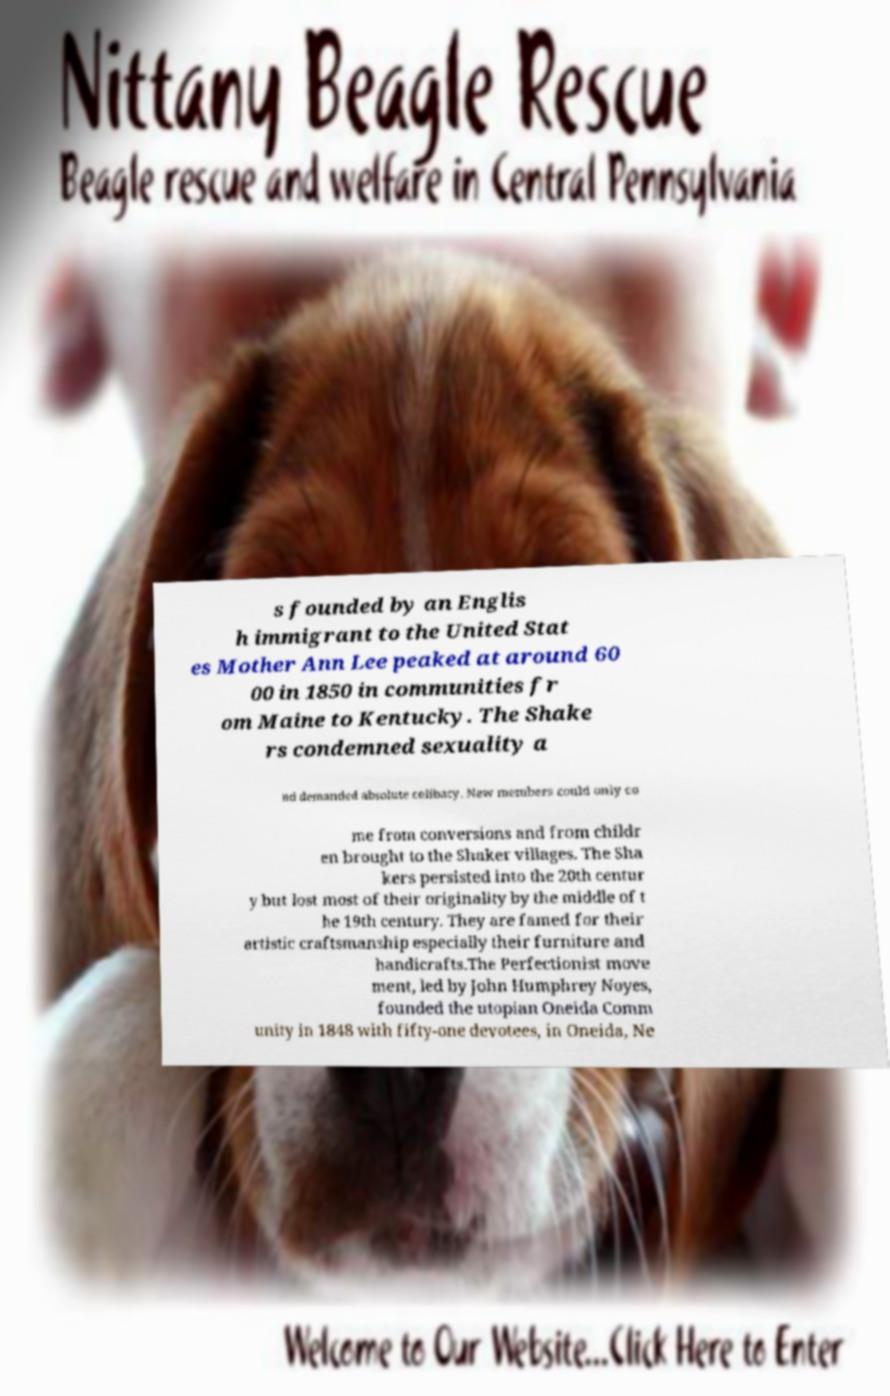Can you accurately transcribe the text from the provided image for me? s founded by an Englis h immigrant to the United Stat es Mother Ann Lee peaked at around 60 00 in 1850 in communities fr om Maine to Kentucky. The Shake rs condemned sexuality a nd demanded absolute celibacy. New members could only co me from conversions and from childr en brought to the Shaker villages. The Sha kers persisted into the 20th centur y but lost most of their originality by the middle of t he 19th century. They are famed for their artistic craftsmanship especially their furniture and handicrafts.The Perfectionist move ment, led by John Humphrey Noyes, founded the utopian Oneida Comm unity in 1848 with fifty-one devotees, in Oneida, Ne 